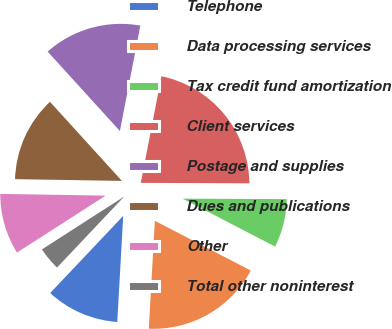<chart> <loc_0><loc_0><loc_500><loc_500><pie_chart><fcel>Telephone<fcel>Data processing services<fcel>Tax credit fund amortization<fcel>Client services<fcel>Postage and supplies<fcel>Dues and publications<fcel>Other<fcel>Total other noninterest<nl><fcel>11.17%<fcel>18.28%<fcel>7.54%<fcel>22.02%<fcel>14.8%<fcel>12.99%<fcel>9.35%<fcel>3.85%<nl></chart> 